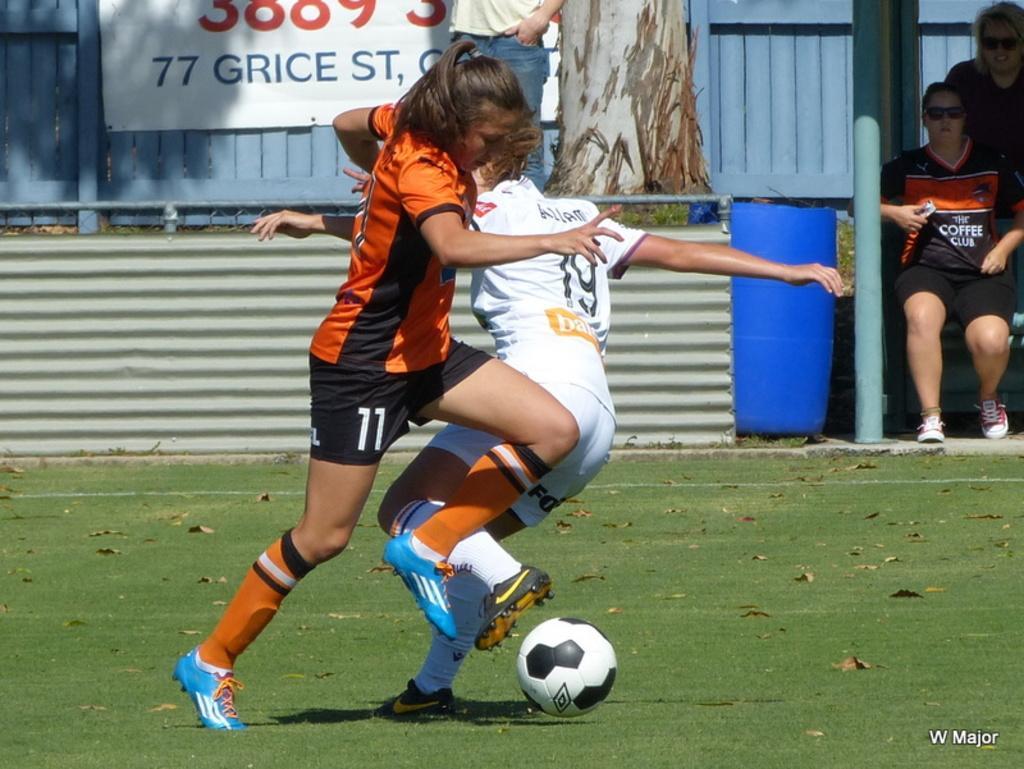Could you give a brief overview of what you see in this image? Here in a ground we can see two persons playing a football. On the background we can see branch, hoarding, roof , blue colour drum and two persons sitting. 